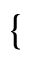Convert formula to latex. <formula><loc_0><loc_0><loc_500><loc_500>\{</formula> 